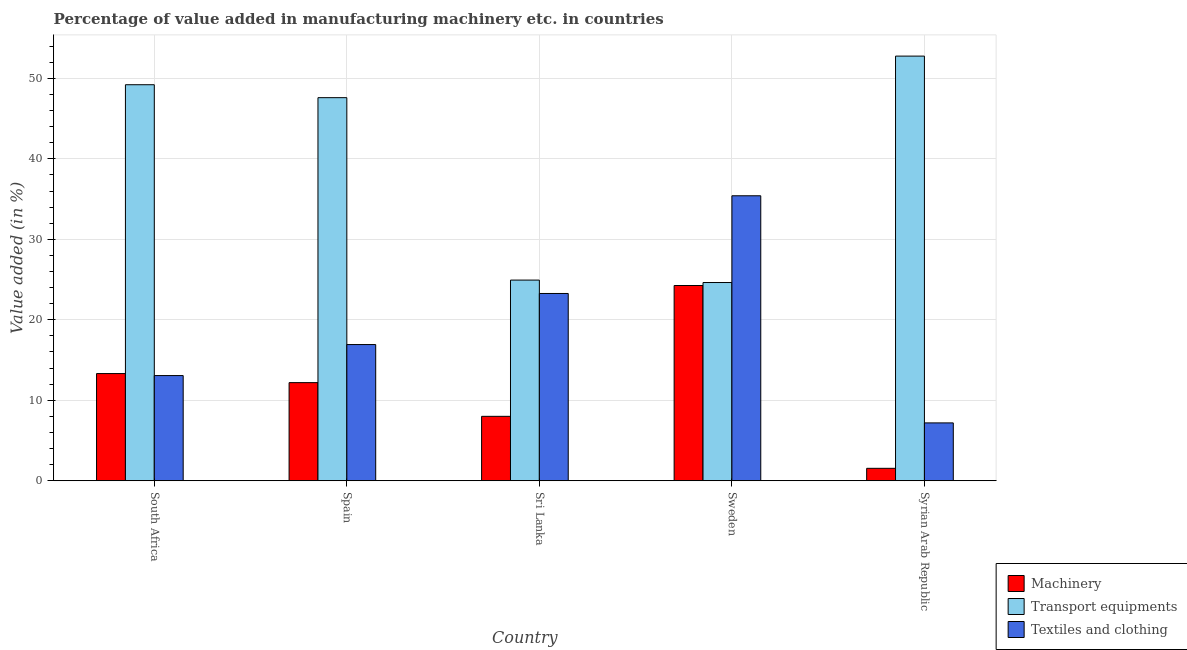How many different coloured bars are there?
Keep it short and to the point. 3. Are the number of bars per tick equal to the number of legend labels?
Your answer should be very brief. Yes. How many bars are there on the 5th tick from the left?
Ensure brevity in your answer.  3. How many bars are there on the 3rd tick from the right?
Keep it short and to the point. 3. In how many cases, is the number of bars for a given country not equal to the number of legend labels?
Keep it short and to the point. 0. What is the value added in manufacturing machinery in South Africa?
Your answer should be very brief. 13.32. Across all countries, what is the maximum value added in manufacturing machinery?
Give a very brief answer. 24.26. Across all countries, what is the minimum value added in manufacturing transport equipments?
Provide a short and direct response. 24.63. In which country was the value added in manufacturing transport equipments minimum?
Make the answer very short. Sweden. What is the total value added in manufacturing textile and clothing in the graph?
Keep it short and to the point. 95.87. What is the difference between the value added in manufacturing textile and clothing in Sri Lanka and that in Sweden?
Your response must be concise. -12.14. What is the difference between the value added in manufacturing machinery in Syrian Arab Republic and the value added in manufacturing transport equipments in South Africa?
Offer a terse response. -47.66. What is the average value added in manufacturing machinery per country?
Ensure brevity in your answer.  11.87. What is the difference between the value added in manufacturing transport equipments and value added in manufacturing machinery in Syrian Arab Republic?
Give a very brief answer. 51.21. In how many countries, is the value added in manufacturing machinery greater than 6 %?
Offer a terse response. 4. What is the ratio of the value added in manufacturing transport equipments in South Africa to that in Sri Lanka?
Your answer should be very brief. 1.97. Is the value added in manufacturing textile and clothing in Spain less than that in Syrian Arab Republic?
Your response must be concise. No. Is the difference between the value added in manufacturing machinery in South Africa and Sweden greater than the difference between the value added in manufacturing textile and clothing in South Africa and Sweden?
Your answer should be very brief. Yes. What is the difference between the highest and the second highest value added in manufacturing machinery?
Your answer should be compact. 10.94. What is the difference between the highest and the lowest value added in manufacturing textile and clothing?
Ensure brevity in your answer.  28.22. Is the sum of the value added in manufacturing transport equipments in Spain and Sweden greater than the maximum value added in manufacturing textile and clothing across all countries?
Give a very brief answer. Yes. What does the 2nd bar from the left in Sri Lanka represents?
Your response must be concise. Transport equipments. What does the 2nd bar from the right in Syrian Arab Republic represents?
Your answer should be very brief. Transport equipments. Are all the bars in the graph horizontal?
Offer a terse response. No. What is the difference between two consecutive major ticks on the Y-axis?
Your answer should be compact. 10. Does the graph contain grids?
Keep it short and to the point. Yes. How are the legend labels stacked?
Offer a very short reply. Vertical. What is the title of the graph?
Offer a very short reply. Percentage of value added in manufacturing machinery etc. in countries. Does "Unemployment benefits" appear as one of the legend labels in the graph?
Give a very brief answer. No. What is the label or title of the Y-axis?
Make the answer very short. Value added (in %). What is the Value added (in %) of Machinery in South Africa?
Provide a succinct answer. 13.32. What is the Value added (in %) of Transport equipments in South Africa?
Your answer should be compact. 49.2. What is the Value added (in %) of Textiles and clothing in South Africa?
Your answer should be compact. 13.07. What is the Value added (in %) of Machinery in Spain?
Your answer should be very brief. 12.2. What is the Value added (in %) in Transport equipments in Spain?
Ensure brevity in your answer.  47.6. What is the Value added (in %) of Textiles and clothing in Spain?
Give a very brief answer. 16.93. What is the Value added (in %) in Machinery in Sri Lanka?
Your answer should be compact. 8.01. What is the Value added (in %) in Transport equipments in Sri Lanka?
Offer a terse response. 24.93. What is the Value added (in %) in Textiles and clothing in Sri Lanka?
Offer a very short reply. 23.27. What is the Value added (in %) of Machinery in Sweden?
Your answer should be compact. 24.26. What is the Value added (in %) of Transport equipments in Sweden?
Offer a very short reply. 24.63. What is the Value added (in %) of Textiles and clothing in Sweden?
Your response must be concise. 35.41. What is the Value added (in %) of Machinery in Syrian Arab Republic?
Make the answer very short. 1.55. What is the Value added (in %) in Transport equipments in Syrian Arab Republic?
Your answer should be very brief. 52.76. What is the Value added (in %) in Textiles and clothing in Syrian Arab Republic?
Your answer should be very brief. 7.19. Across all countries, what is the maximum Value added (in %) in Machinery?
Make the answer very short. 24.26. Across all countries, what is the maximum Value added (in %) of Transport equipments?
Your answer should be very brief. 52.76. Across all countries, what is the maximum Value added (in %) of Textiles and clothing?
Offer a terse response. 35.41. Across all countries, what is the minimum Value added (in %) of Machinery?
Offer a terse response. 1.55. Across all countries, what is the minimum Value added (in %) of Transport equipments?
Give a very brief answer. 24.63. Across all countries, what is the minimum Value added (in %) in Textiles and clothing?
Keep it short and to the point. 7.19. What is the total Value added (in %) of Machinery in the graph?
Keep it short and to the point. 59.33. What is the total Value added (in %) in Transport equipments in the graph?
Ensure brevity in your answer.  199.13. What is the total Value added (in %) of Textiles and clothing in the graph?
Keep it short and to the point. 95.87. What is the difference between the Value added (in %) of Transport equipments in South Africa and that in Spain?
Keep it short and to the point. 1.61. What is the difference between the Value added (in %) in Textiles and clothing in South Africa and that in Spain?
Offer a terse response. -3.85. What is the difference between the Value added (in %) of Machinery in South Africa and that in Sri Lanka?
Make the answer very short. 5.31. What is the difference between the Value added (in %) of Transport equipments in South Africa and that in Sri Lanka?
Offer a terse response. 24.27. What is the difference between the Value added (in %) in Textiles and clothing in South Africa and that in Sri Lanka?
Keep it short and to the point. -10.2. What is the difference between the Value added (in %) of Machinery in South Africa and that in Sweden?
Your answer should be very brief. -10.94. What is the difference between the Value added (in %) of Transport equipments in South Africa and that in Sweden?
Offer a very short reply. 24.57. What is the difference between the Value added (in %) in Textiles and clothing in South Africa and that in Sweden?
Keep it short and to the point. -22.34. What is the difference between the Value added (in %) in Machinery in South Africa and that in Syrian Arab Republic?
Offer a very short reply. 11.77. What is the difference between the Value added (in %) in Transport equipments in South Africa and that in Syrian Arab Republic?
Ensure brevity in your answer.  -3.56. What is the difference between the Value added (in %) in Textiles and clothing in South Africa and that in Syrian Arab Republic?
Keep it short and to the point. 5.88. What is the difference between the Value added (in %) in Machinery in Spain and that in Sri Lanka?
Offer a very short reply. 4.19. What is the difference between the Value added (in %) in Transport equipments in Spain and that in Sri Lanka?
Your answer should be very brief. 22.66. What is the difference between the Value added (in %) in Textiles and clothing in Spain and that in Sri Lanka?
Offer a terse response. -6.34. What is the difference between the Value added (in %) of Machinery in Spain and that in Sweden?
Your answer should be compact. -12.07. What is the difference between the Value added (in %) of Transport equipments in Spain and that in Sweden?
Offer a terse response. 22.97. What is the difference between the Value added (in %) of Textiles and clothing in Spain and that in Sweden?
Give a very brief answer. -18.48. What is the difference between the Value added (in %) in Machinery in Spain and that in Syrian Arab Republic?
Offer a very short reply. 10.65. What is the difference between the Value added (in %) in Transport equipments in Spain and that in Syrian Arab Republic?
Provide a short and direct response. -5.16. What is the difference between the Value added (in %) of Textiles and clothing in Spain and that in Syrian Arab Republic?
Make the answer very short. 9.73. What is the difference between the Value added (in %) in Machinery in Sri Lanka and that in Sweden?
Provide a succinct answer. -16.25. What is the difference between the Value added (in %) in Transport equipments in Sri Lanka and that in Sweden?
Your answer should be compact. 0.3. What is the difference between the Value added (in %) of Textiles and clothing in Sri Lanka and that in Sweden?
Ensure brevity in your answer.  -12.14. What is the difference between the Value added (in %) in Machinery in Sri Lanka and that in Syrian Arab Republic?
Make the answer very short. 6.46. What is the difference between the Value added (in %) in Transport equipments in Sri Lanka and that in Syrian Arab Republic?
Give a very brief answer. -27.83. What is the difference between the Value added (in %) of Textiles and clothing in Sri Lanka and that in Syrian Arab Republic?
Offer a terse response. 16.08. What is the difference between the Value added (in %) in Machinery in Sweden and that in Syrian Arab Republic?
Provide a succinct answer. 22.71. What is the difference between the Value added (in %) in Transport equipments in Sweden and that in Syrian Arab Republic?
Provide a succinct answer. -28.13. What is the difference between the Value added (in %) in Textiles and clothing in Sweden and that in Syrian Arab Republic?
Offer a very short reply. 28.22. What is the difference between the Value added (in %) in Machinery in South Africa and the Value added (in %) in Transport equipments in Spain?
Your answer should be compact. -34.28. What is the difference between the Value added (in %) of Machinery in South Africa and the Value added (in %) of Textiles and clothing in Spain?
Offer a terse response. -3.61. What is the difference between the Value added (in %) in Transport equipments in South Africa and the Value added (in %) in Textiles and clothing in Spain?
Offer a terse response. 32.28. What is the difference between the Value added (in %) in Machinery in South Africa and the Value added (in %) in Transport equipments in Sri Lanka?
Ensure brevity in your answer.  -11.61. What is the difference between the Value added (in %) of Machinery in South Africa and the Value added (in %) of Textiles and clothing in Sri Lanka?
Make the answer very short. -9.95. What is the difference between the Value added (in %) in Transport equipments in South Africa and the Value added (in %) in Textiles and clothing in Sri Lanka?
Make the answer very short. 25.93. What is the difference between the Value added (in %) in Machinery in South Africa and the Value added (in %) in Transport equipments in Sweden?
Your answer should be compact. -11.31. What is the difference between the Value added (in %) of Machinery in South Africa and the Value added (in %) of Textiles and clothing in Sweden?
Provide a succinct answer. -22.09. What is the difference between the Value added (in %) of Transport equipments in South Africa and the Value added (in %) of Textiles and clothing in Sweden?
Make the answer very short. 13.8. What is the difference between the Value added (in %) in Machinery in South Africa and the Value added (in %) in Transport equipments in Syrian Arab Republic?
Provide a short and direct response. -39.44. What is the difference between the Value added (in %) in Machinery in South Africa and the Value added (in %) in Textiles and clothing in Syrian Arab Republic?
Offer a very short reply. 6.13. What is the difference between the Value added (in %) in Transport equipments in South Africa and the Value added (in %) in Textiles and clothing in Syrian Arab Republic?
Provide a succinct answer. 42.01. What is the difference between the Value added (in %) of Machinery in Spain and the Value added (in %) of Transport equipments in Sri Lanka?
Your response must be concise. -12.74. What is the difference between the Value added (in %) in Machinery in Spain and the Value added (in %) in Textiles and clothing in Sri Lanka?
Your answer should be compact. -11.08. What is the difference between the Value added (in %) of Transport equipments in Spain and the Value added (in %) of Textiles and clothing in Sri Lanka?
Offer a terse response. 24.33. What is the difference between the Value added (in %) of Machinery in Spain and the Value added (in %) of Transport equipments in Sweden?
Provide a succinct answer. -12.44. What is the difference between the Value added (in %) in Machinery in Spain and the Value added (in %) in Textiles and clothing in Sweden?
Offer a terse response. -23.21. What is the difference between the Value added (in %) of Transport equipments in Spain and the Value added (in %) of Textiles and clothing in Sweden?
Your answer should be compact. 12.19. What is the difference between the Value added (in %) of Machinery in Spain and the Value added (in %) of Transport equipments in Syrian Arab Republic?
Offer a very short reply. -40.57. What is the difference between the Value added (in %) of Machinery in Spain and the Value added (in %) of Textiles and clothing in Syrian Arab Republic?
Give a very brief answer. 5. What is the difference between the Value added (in %) of Transport equipments in Spain and the Value added (in %) of Textiles and clothing in Syrian Arab Republic?
Provide a short and direct response. 40.41. What is the difference between the Value added (in %) of Machinery in Sri Lanka and the Value added (in %) of Transport equipments in Sweden?
Offer a terse response. -16.62. What is the difference between the Value added (in %) in Machinery in Sri Lanka and the Value added (in %) in Textiles and clothing in Sweden?
Provide a succinct answer. -27.4. What is the difference between the Value added (in %) in Transport equipments in Sri Lanka and the Value added (in %) in Textiles and clothing in Sweden?
Make the answer very short. -10.47. What is the difference between the Value added (in %) of Machinery in Sri Lanka and the Value added (in %) of Transport equipments in Syrian Arab Republic?
Your response must be concise. -44.75. What is the difference between the Value added (in %) of Machinery in Sri Lanka and the Value added (in %) of Textiles and clothing in Syrian Arab Republic?
Offer a terse response. 0.82. What is the difference between the Value added (in %) in Transport equipments in Sri Lanka and the Value added (in %) in Textiles and clothing in Syrian Arab Republic?
Provide a short and direct response. 17.74. What is the difference between the Value added (in %) of Machinery in Sweden and the Value added (in %) of Transport equipments in Syrian Arab Republic?
Ensure brevity in your answer.  -28.5. What is the difference between the Value added (in %) in Machinery in Sweden and the Value added (in %) in Textiles and clothing in Syrian Arab Republic?
Offer a terse response. 17.07. What is the difference between the Value added (in %) in Transport equipments in Sweden and the Value added (in %) in Textiles and clothing in Syrian Arab Republic?
Offer a terse response. 17.44. What is the average Value added (in %) in Machinery per country?
Offer a terse response. 11.87. What is the average Value added (in %) of Transport equipments per country?
Provide a succinct answer. 39.83. What is the average Value added (in %) of Textiles and clothing per country?
Make the answer very short. 19.17. What is the difference between the Value added (in %) in Machinery and Value added (in %) in Transport equipments in South Africa?
Offer a terse response. -35.88. What is the difference between the Value added (in %) of Machinery and Value added (in %) of Textiles and clothing in South Africa?
Give a very brief answer. 0.25. What is the difference between the Value added (in %) in Transport equipments and Value added (in %) in Textiles and clothing in South Africa?
Offer a terse response. 36.13. What is the difference between the Value added (in %) in Machinery and Value added (in %) in Transport equipments in Spain?
Your answer should be very brief. -35.4. What is the difference between the Value added (in %) in Machinery and Value added (in %) in Textiles and clothing in Spain?
Make the answer very short. -4.73. What is the difference between the Value added (in %) in Transport equipments and Value added (in %) in Textiles and clothing in Spain?
Your answer should be very brief. 30.67. What is the difference between the Value added (in %) of Machinery and Value added (in %) of Transport equipments in Sri Lanka?
Make the answer very short. -16.93. What is the difference between the Value added (in %) of Machinery and Value added (in %) of Textiles and clothing in Sri Lanka?
Keep it short and to the point. -15.26. What is the difference between the Value added (in %) in Transport equipments and Value added (in %) in Textiles and clothing in Sri Lanka?
Offer a terse response. 1.66. What is the difference between the Value added (in %) in Machinery and Value added (in %) in Transport equipments in Sweden?
Your answer should be compact. -0.37. What is the difference between the Value added (in %) of Machinery and Value added (in %) of Textiles and clothing in Sweden?
Your response must be concise. -11.15. What is the difference between the Value added (in %) of Transport equipments and Value added (in %) of Textiles and clothing in Sweden?
Give a very brief answer. -10.78. What is the difference between the Value added (in %) of Machinery and Value added (in %) of Transport equipments in Syrian Arab Republic?
Your answer should be very brief. -51.21. What is the difference between the Value added (in %) of Machinery and Value added (in %) of Textiles and clothing in Syrian Arab Republic?
Offer a very short reply. -5.64. What is the difference between the Value added (in %) in Transport equipments and Value added (in %) in Textiles and clothing in Syrian Arab Republic?
Ensure brevity in your answer.  45.57. What is the ratio of the Value added (in %) of Machinery in South Africa to that in Spain?
Ensure brevity in your answer.  1.09. What is the ratio of the Value added (in %) in Transport equipments in South Africa to that in Spain?
Make the answer very short. 1.03. What is the ratio of the Value added (in %) of Textiles and clothing in South Africa to that in Spain?
Provide a short and direct response. 0.77. What is the ratio of the Value added (in %) of Machinery in South Africa to that in Sri Lanka?
Make the answer very short. 1.66. What is the ratio of the Value added (in %) in Transport equipments in South Africa to that in Sri Lanka?
Your answer should be very brief. 1.97. What is the ratio of the Value added (in %) in Textiles and clothing in South Africa to that in Sri Lanka?
Your answer should be compact. 0.56. What is the ratio of the Value added (in %) in Machinery in South Africa to that in Sweden?
Ensure brevity in your answer.  0.55. What is the ratio of the Value added (in %) of Transport equipments in South Africa to that in Sweden?
Your answer should be compact. 2. What is the ratio of the Value added (in %) in Textiles and clothing in South Africa to that in Sweden?
Your response must be concise. 0.37. What is the ratio of the Value added (in %) of Machinery in South Africa to that in Syrian Arab Republic?
Make the answer very short. 8.61. What is the ratio of the Value added (in %) of Transport equipments in South Africa to that in Syrian Arab Republic?
Provide a short and direct response. 0.93. What is the ratio of the Value added (in %) of Textiles and clothing in South Africa to that in Syrian Arab Republic?
Make the answer very short. 1.82. What is the ratio of the Value added (in %) of Machinery in Spain to that in Sri Lanka?
Keep it short and to the point. 1.52. What is the ratio of the Value added (in %) of Transport equipments in Spain to that in Sri Lanka?
Offer a terse response. 1.91. What is the ratio of the Value added (in %) of Textiles and clothing in Spain to that in Sri Lanka?
Your response must be concise. 0.73. What is the ratio of the Value added (in %) of Machinery in Spain to that in Sweden?
Provide a succinct answer. 0.5. What is the ratio of the Value added (in %) in Transport equipments in Spain to that in Sweden?
Your answer should be compact. 1.93. What is the ratio of the Value added (in %) in Textiles and clothing in Spain to that in Sweden?
Provide a short and direct response. 0.48. What is the ratio of the Value added (in %) of Machinery in Spain to that in Syrian Arab Republic?
Your answer should be compact. 7.88. What is the ratio of the Value added (in %) in Transport equipments in Spain to that in Syrian Arab Republic?
Make the answer very short. 0.9. What is the ratio of the Value added (in %) of Textiles and clothing in Spain to that in Syrian Arab Republic?
Keep it short and to the point. 2.35. What is the ratio of the Value added (in %) of Machinery in Sri Lanka to that in Sweden?
Provide a succinct answer. 0.33. What is the ratio of the Value added (in %) of Transport equipments in Sri Lanka to that in Sweden?
Your response must be concise. 1.01. What is the ratio of the Value added (in %) of Textiles and clothing in Sri Lanka to that in Sweden?
Offer a terse response. 0.66. What is the ratio of the Value added (in %) in Machinery in Sri Lanka to that in Syrian Arab Republic?
Your response must be concise. 5.17. What is the ratio of the Value added (in %) in Transport equipments in Sri Lanka to that in Syrian Arab Republic?
Make the answer very short. 0.47. What is the ratio of the Value added (in %) of Textiles and clothing in Sri Lanka to that in Syrian Arab Republic?
Your answer should be compact. 3.24. What is the ratio of the Value added (in %) of Machinery in Sweden to that in Syrian Arab Republic?
Provide a short and direct response. 15.67. What is the ratio of the Value added (in %) in Transport equipments in Sweden to that in Syrian Arab Republic?
Ensure brevity in your answer.  0.47. What is the ratio of the Value added (in %) in Textiles and clothing in Sweden to that in Syrian Arab Republic?
Your response must be concise. 4.92. What is the difference between the highest and the second highest Value added (in %) of Machinery?
Provide a succinct answer. 10.94. What is the difference between the highest and the second highest Value added (in %) in Transport equipments?
Keep it short and to the point. 3.56. What is the difference between the highest and the second highest Value added (in %) in Textiles and clothing?
Offer a terse response. 12.14. What is the difference between the highest and the lowest Value added (in %) of Machinery?
Keep it short and to the point. 22.71. What is the difference between the highest and the lowest Value added (in %) in Transport equipments?
Offer a very short reply. 28.13. What is the difference between the highest and the lowest Value added (in %) of Textiles and clothing?
Offer a very short reply. 28.22. 